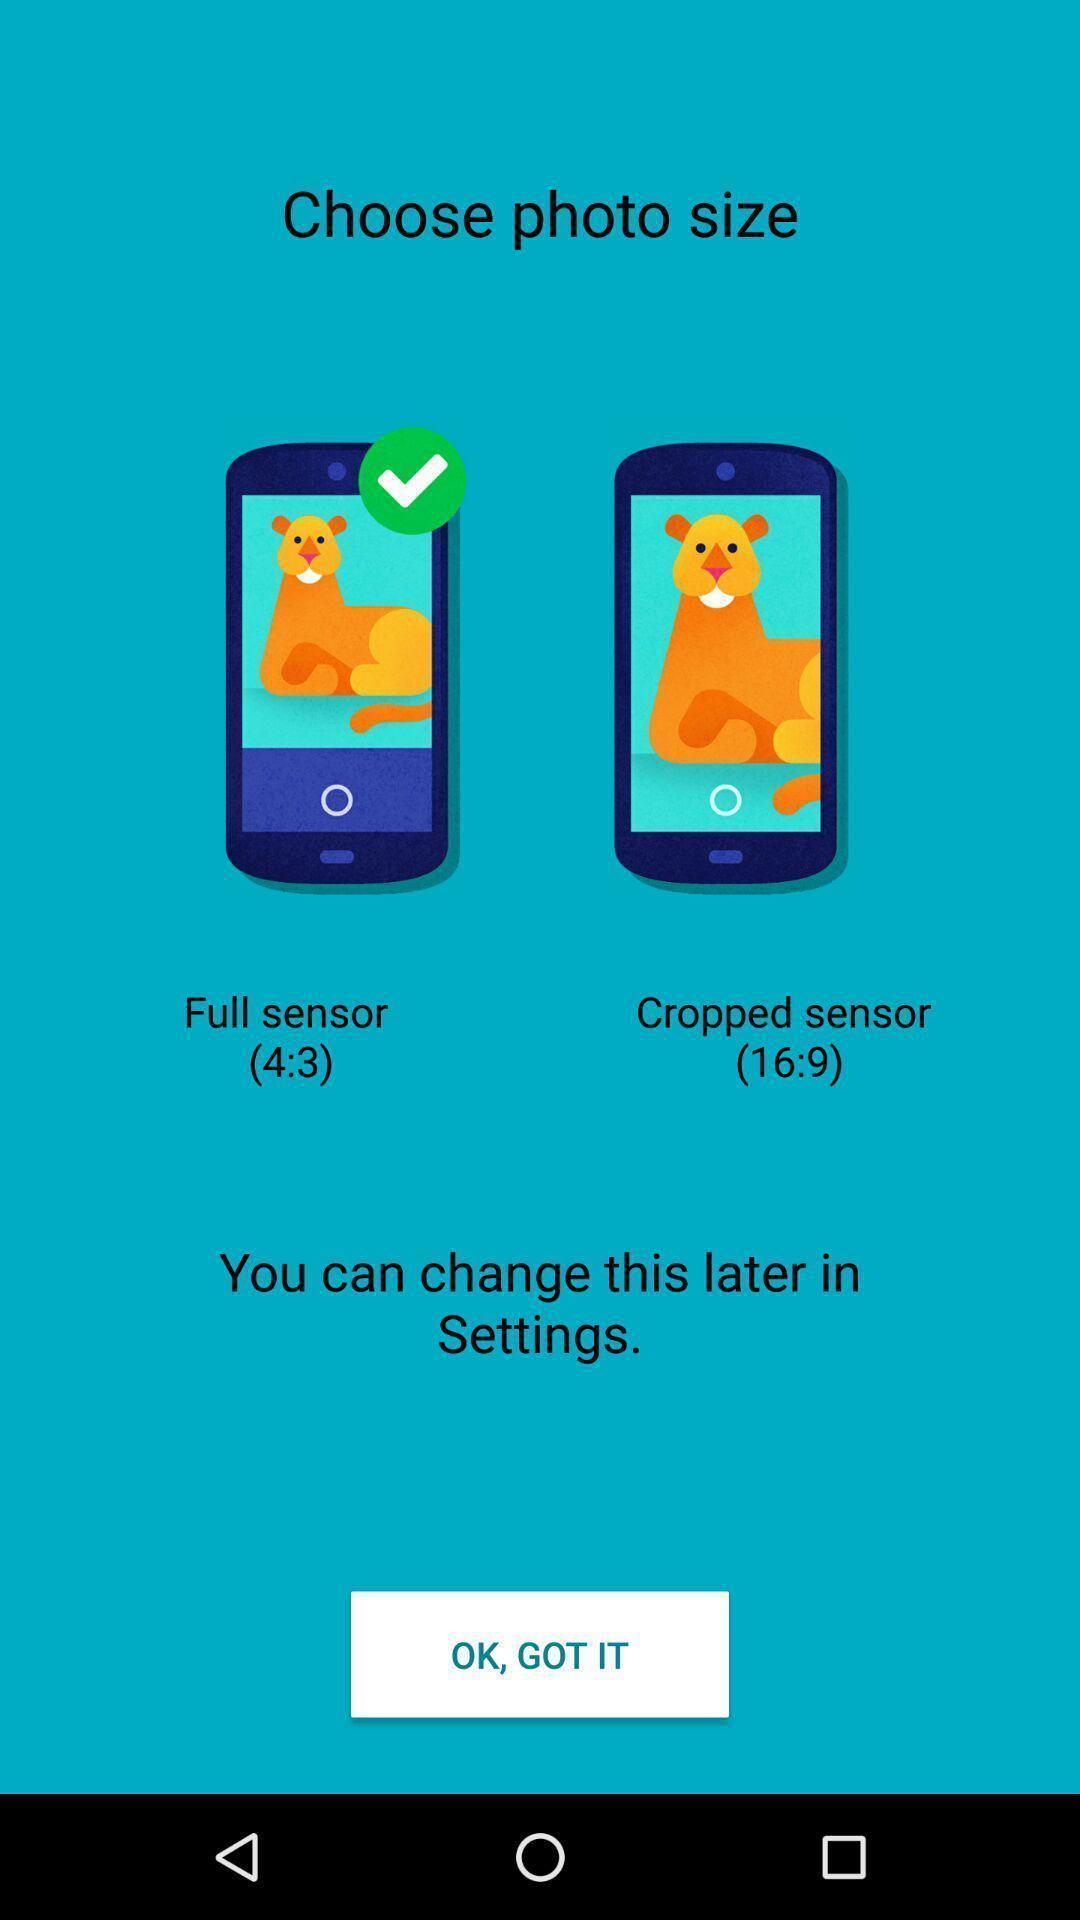Give me a narrative description of this picture. Welcome page of theme app. 